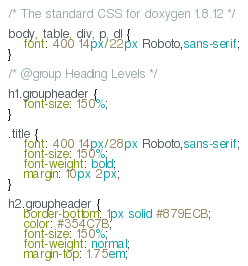Convert code to text. <code><loc_0><loc_0><loc_500><loc_500><_CSS_>/* The standard CSS for doxygen 1.8.12 */

body, table, div, p, dl {
	font: 400 14px/22px Roboto,sans-serif;
}

/* @group Heading Levels */

h1.groupheader {
	font-size: 150%;
}

.title {
	font: 400 14px/28px Roboto,sans-serif;
	font-size: 150%;
	font-weight: bold;
	margin: 10px 2px;
}

h2.groupheader {
	border-bottom: 1px solid #879ECB;
	color: #354C7B;
	font-size: 150%;
	font-weight: normal;
	margin-top: 1.75em;</code> 